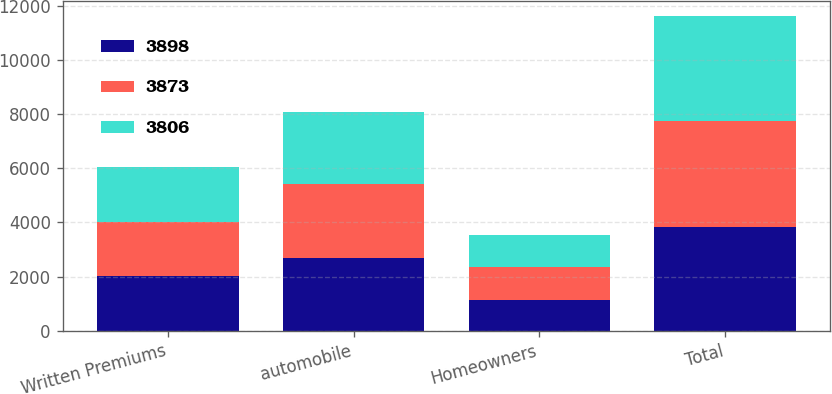<chart> <loc_0><loc_0><loc_500><loc_500><stacked_bar_chart><ecel><fcel>Written Premiums<fcel>automobile<fcel>Homeowners<fcel>Total<nl><fcel>3898<fcel>2016<fcel>2694<fcel>1143<fcel>3837<nl><fcel>3873<fcel>2015<fcel>2721<fcel>1197<fcel>3918<nl><fcel>3806<fcel>2014<fcel>2659<fcel>1202<fcel>3861<nl></chart> 